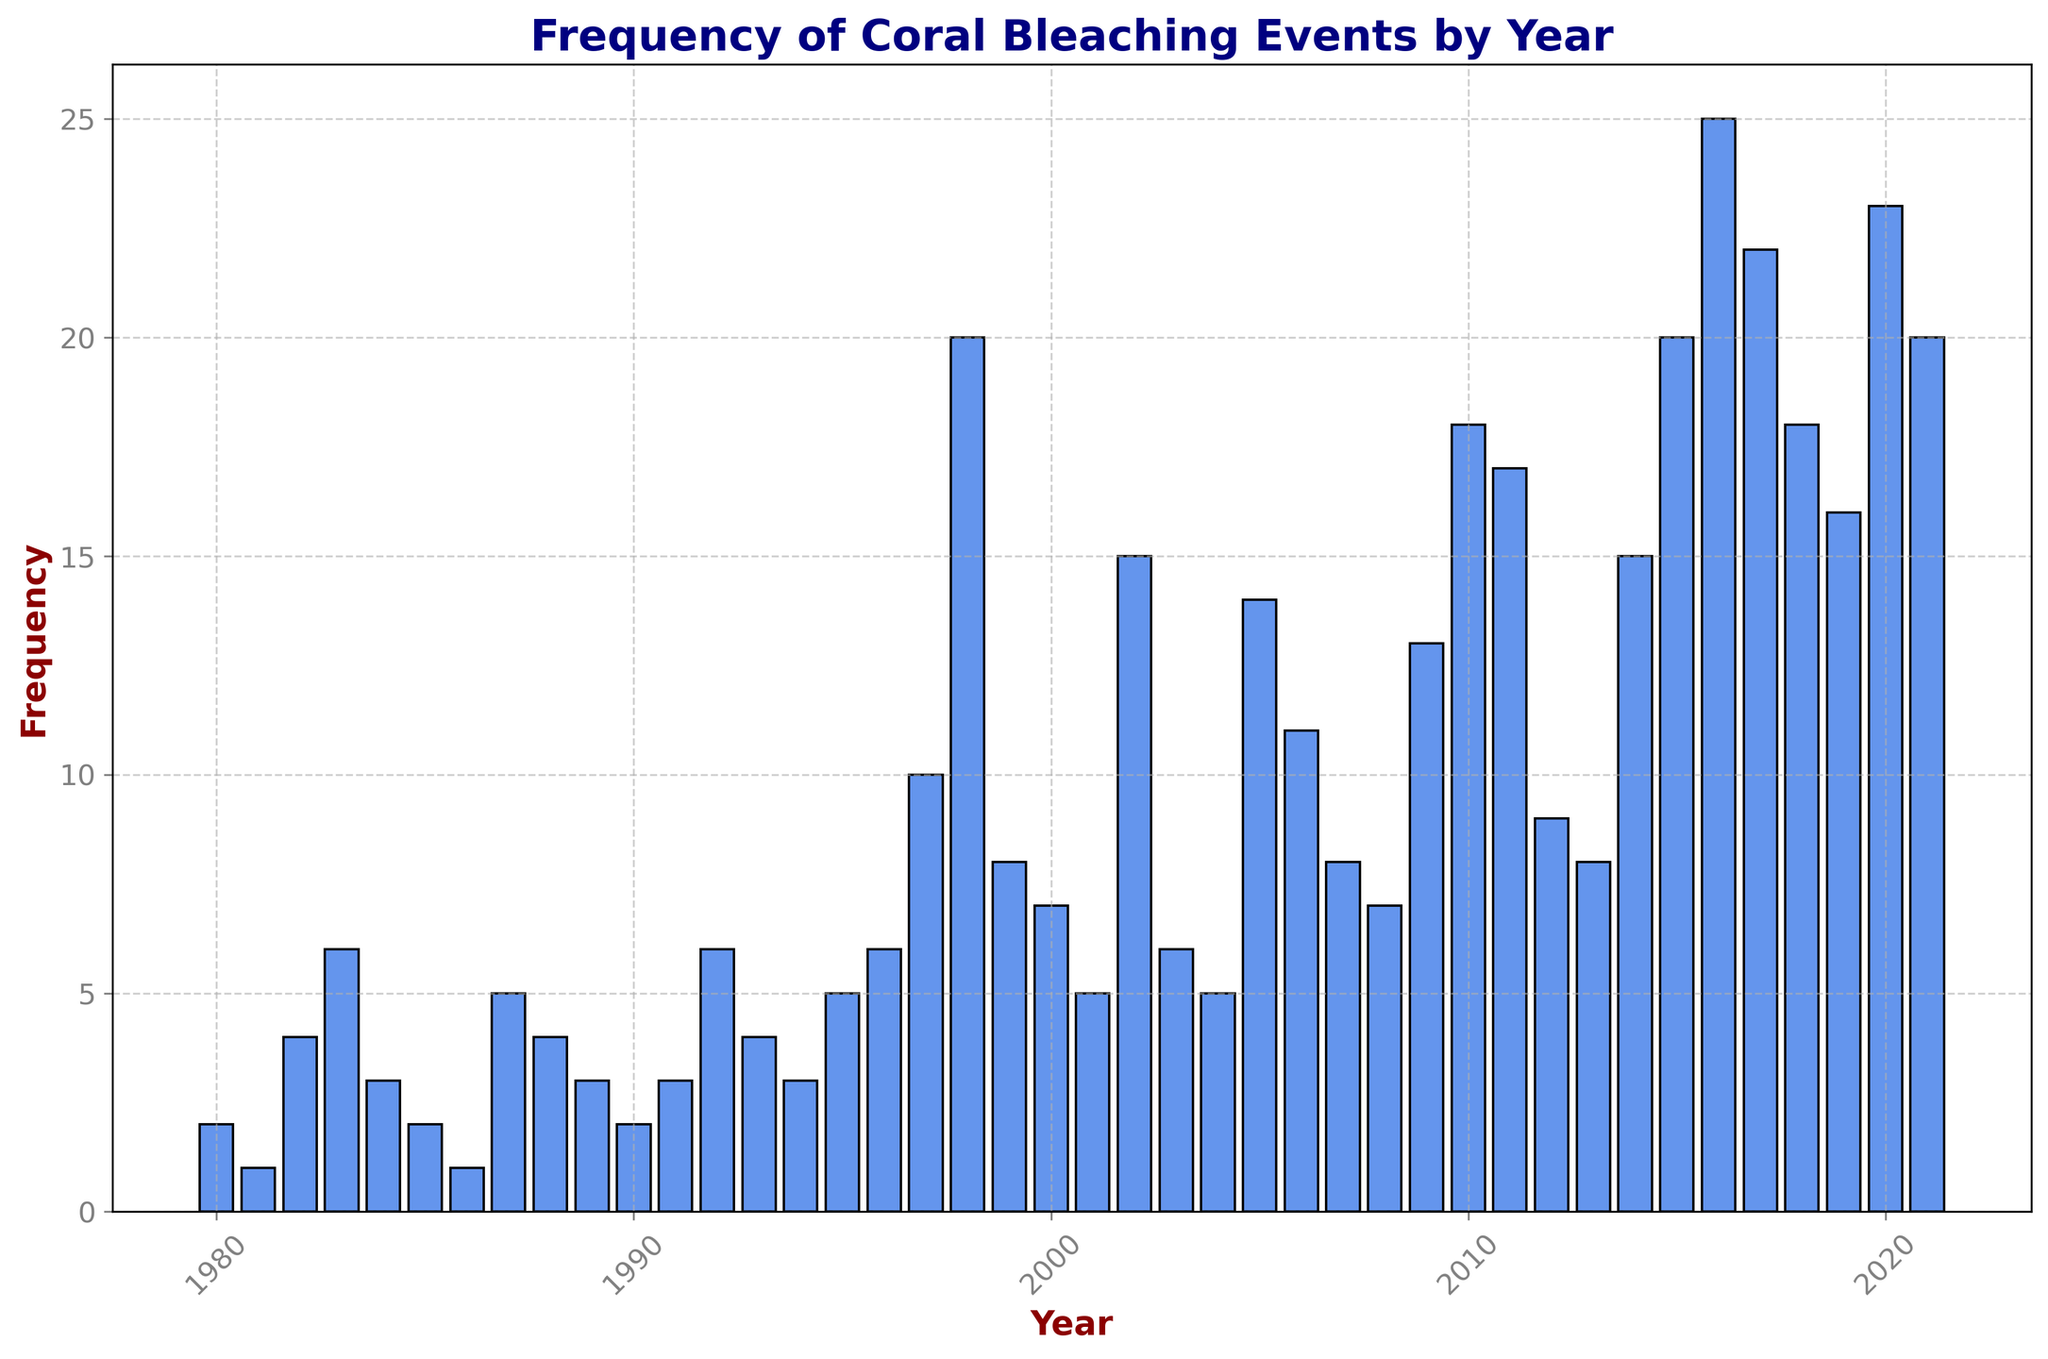What is the overall trend in the frequency of coral bleaching events over the years? Observing the height of bars in the histogram, the frequency of coral bleaching events generally increases over the years, especially after the year 1997 where a significant rise can be seen.
Answer: Increasing Which year has the highest frequency of coral bleaching events? Identifying the tallest bar in the histogram, the highest frequency of coral bleaching events occurs in the year 2016.
Answer: 2016 How does the frequency in 1998 compare to that in 2010? Compare the heights of the bars for the years 1998 and 2010. The bar for 1998 is taller than that for 2010.
Answer: 1998 > 2010 Which years have a frequency of coral bleaching events greater than 15? Look for bars taller than the 15 mark on the y-axis. The years are 1998, 2002, 2005, 2010, 2011, 2015, 2016, 2017, 2020, 2021.
Answer: 1998, 2002, 2005, 2010, 2011, 2015, 2016, 2017, 2020, 2021 How does the frequency in the year 1987 compare to 1983? Compare the height of the bars for the years 1987 and 1983. The bar for 1987 is shorter than that for 1983.
Answer: 1987 < 1983 What are the top three years with the highest frequency of coral bleaching events? Identify the three tallest bars in the histogram. These occur in the years 2016, 2021, and 2020.
Answer: 2016, 2021, 2020 What is the average frequency of coral bleaching events for the years 2000 to 2005? Add the frequencies of the years 2000 (7), 2001 (5), 2002 (15), 2003 (6), 2004 (5), 2005 (14) and divide the total by 6. The average is (7+5+15+6+5+14)/6 = 8.6667.
Answer: 8.67 Which years had a frequency of 10 or more coral bleaching events? Identify the years corresponding to bars with a height of 10 or more. These years are 1997, 1998, 2002, 2005, 2006, 2009, 2010, 2011, 2014, 2015, 2016, 2017, 2018, 2019, 2020, and 2021.
Answer: 1997, 1998, 2002, 2005, 2006, 2009, 2010, 2011, 2014, 2015, 2016, 2017, 2018, 2019, 2020, 2021 How does the frequency of bleaching events in the first decade (1980-1989) compare to the last decade (2011-2021)? Sum the frequencies from 1980 to 1989 (2+1+4+6+3+2+1+5+4+3 = 31) and from 2011 to 2021 (17+9+8+15+20+25+22+18+16+23+20 = 193), then compare the sums.
Answer: First decade < Last decade What can be inferred from the sudden spike in frequency starting in the late 1990s? Looking at the histogram, there's a notable increase in the height of the bars from 1997 onwards, suggesting a rise in the frequency of coral bleaching events, indicating a potential change or shift in environmental conditions or reporting.
Answer: Increase in frequency 